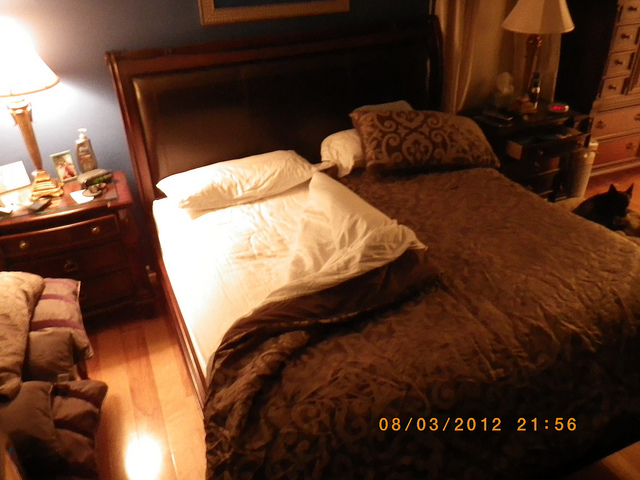Read all the text in this image. 08 / 03 / 2012 21:56 